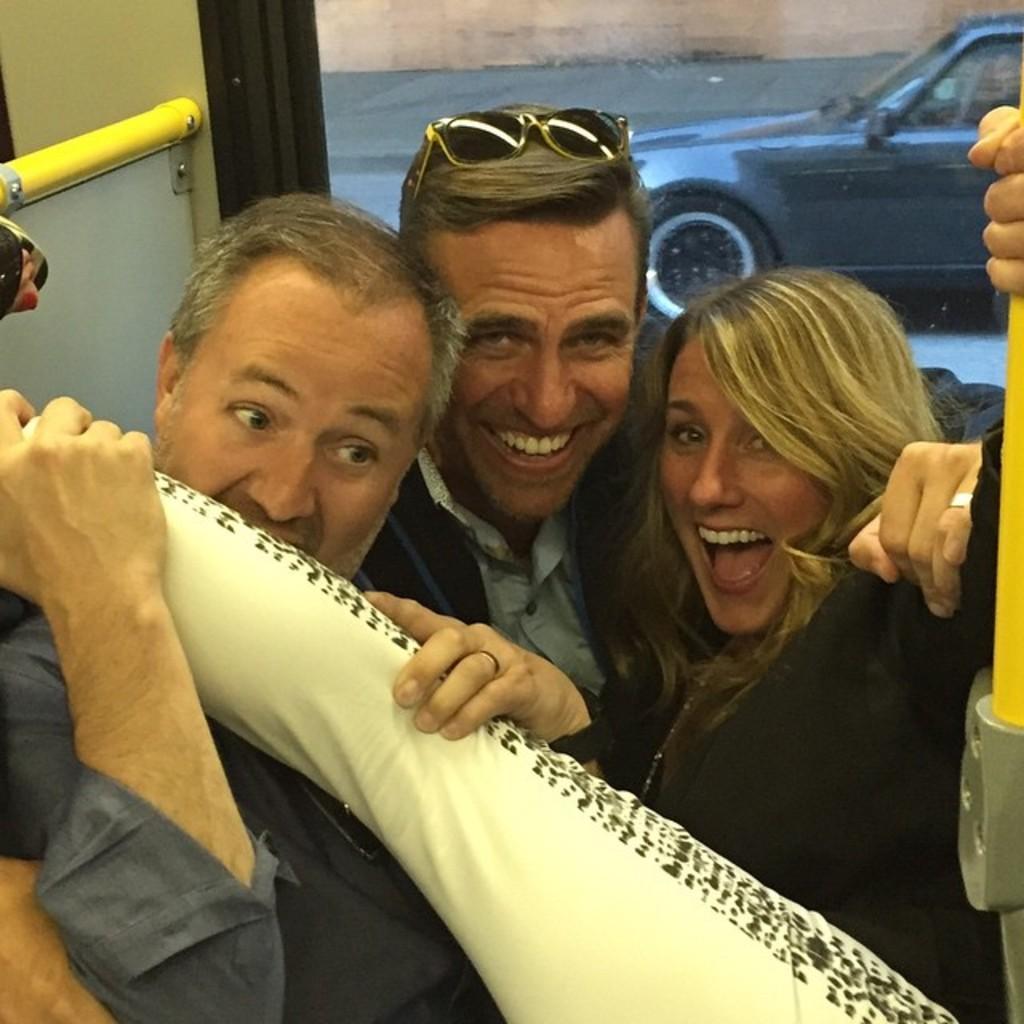In one or two sentences, can you explain what this image depicts? This is an inside view of a vehicle. We can see three people. A man is holding an object on the left side. We can see a car, path and a wall in the background. 